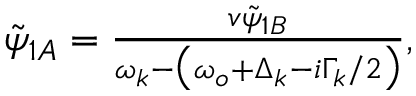<formula> <loc_0><loc_0><loc_500><loc_500>\begin{array} { r } { \tilde { \psi } _ { 1 A } = \frac { v \tilde { \psi } _ { 1 B } } { \omega _ { k } - \left ( \omega _ { o } + \Delta _ { k } - i \Gamma _ { k } / 2 \right ) } , } \end{array}</formula> 